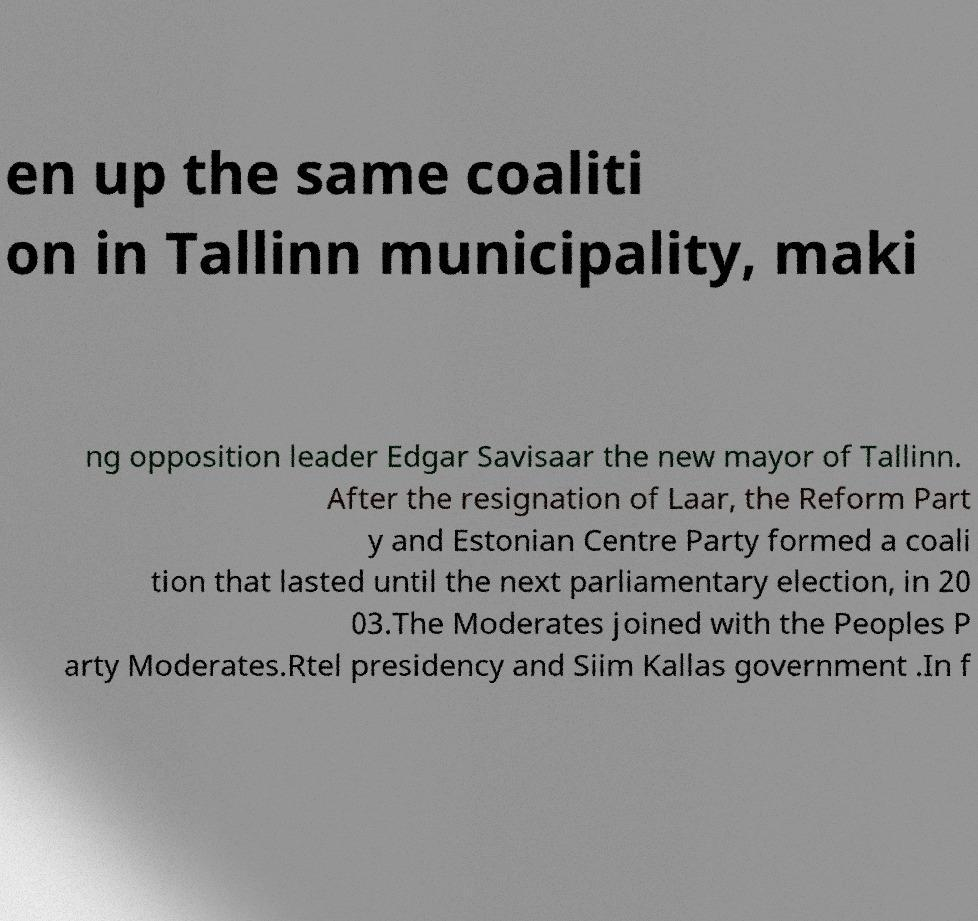I need the written content from this picture converted into text. Can you do that? en up the same coaliti on in Tallinn municipality, maki ng opposition leader Edgar Savisaar the new mayor of Tallinn. After the resignation of Laar, the Reform Part y and Estonian Centre Party formed a coali tion that lasted until the next parliamentary election, in 20 03.The Moderates joined with the Peoples P arty Moderates.Rtel presidency and Siim Kallas government .In f 